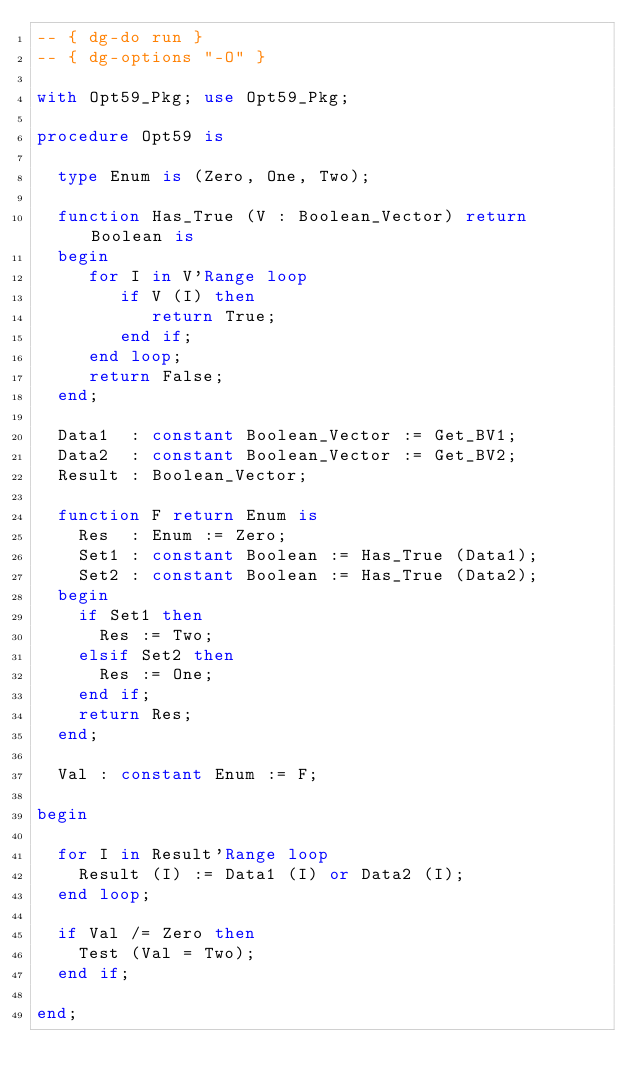Convert code to text. <code><loc_0><loc_0><loc_500><loc_500><_Ada_>-- { dg-do run }
-- { dg-options "-O" }

with Opt59_Pkg; use Opt59_Pkg;

procedure Opt59 is

  type Enum is (Zero, One, Two);

  function Has_True (V : Boolean_Vector) return Boolean is
  begin
     for I in V'Range loop
        if V (I) then
           return True;
        end if;
     end loop;
     return False;
  end;

  Data1  : constant Boolean_Vector := Get_BV1;
  Data2  : constant Boolean_Vector := Get_BV2;
  Result : Boolean_Vector;

  function F return Enum is
    Res  : Enum := Zero;
    Set1 : constant Boolean := Has_True (Data1);
    Set2 : constant Boolean := Has_True (Data2);
  begin
    if Set1 then
      Res := Two;
    elsif Set2 then
      Res := One;
    end if;
    return Res;
  end;

  Val : constant Enum := F;

begin

  for I in Result'Range loop
    Result (I) := Data1 (I) or Data2 (I);
  end loop;

  if Val /= Zero then
    Test (Val = Two);
  end if;

end;
</code> 